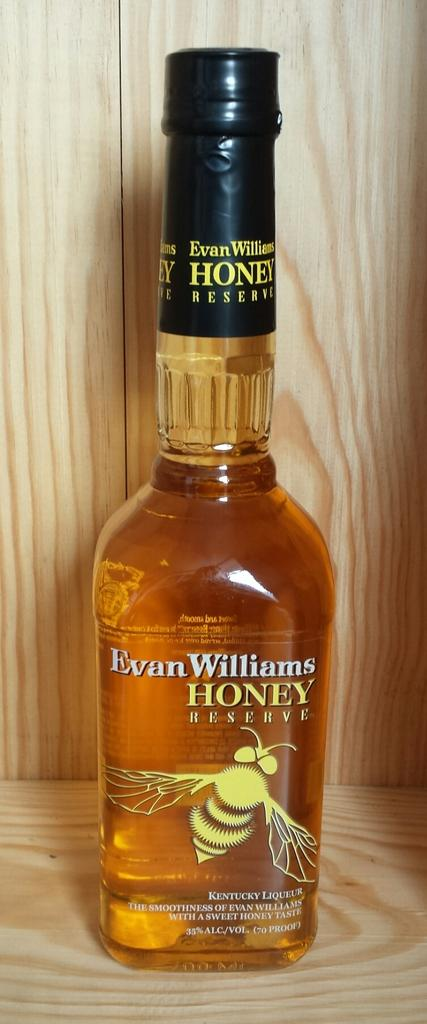<image>
Share a concise interpretation of the image provided. A bottle of Evan Williams Honey Reserve features a bee on it. 